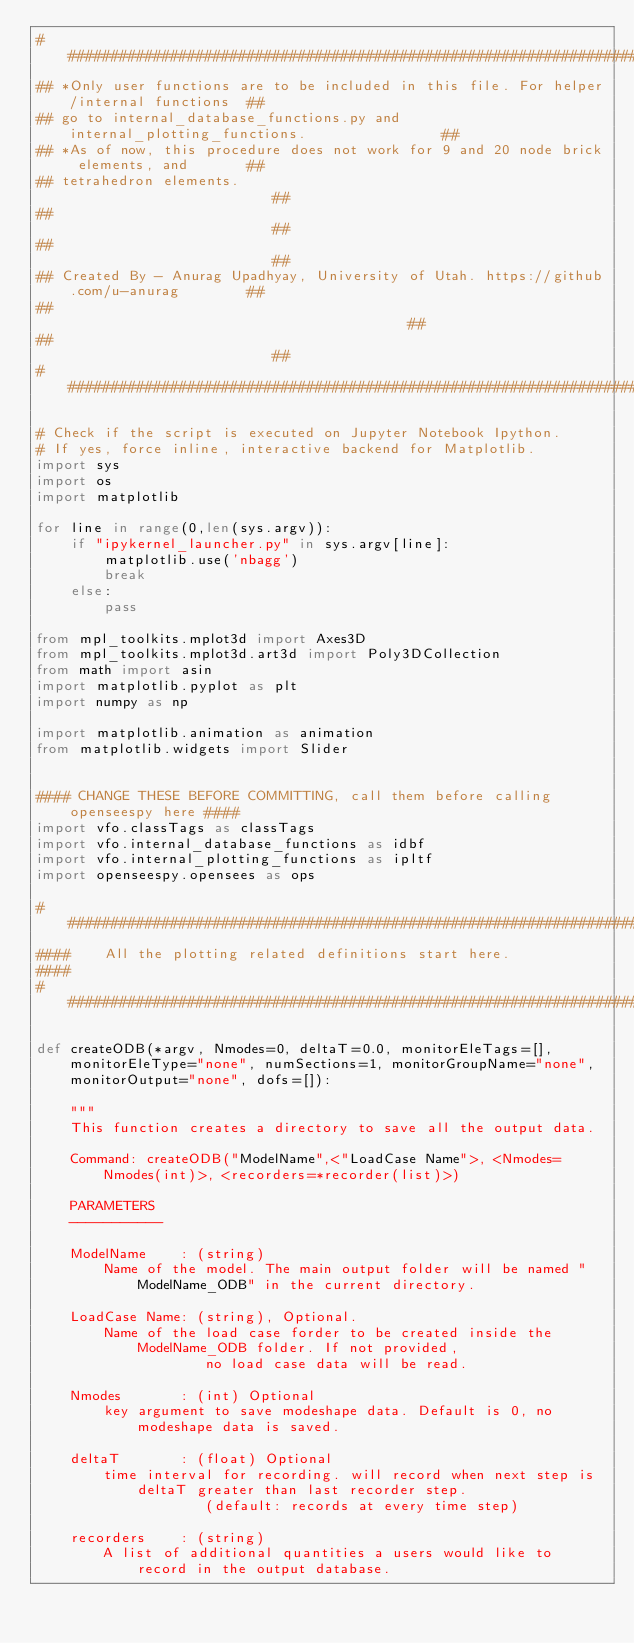<code> <loc_0><loc_0><loc_500><loc_500><_Python_>##########################################################################################
## *Only user functions are to be included in this file. For helper/internal functions	##
## go to internal_database_functions.py and internal_plotting_functions.                ##
## *As of now, this procedure does not work for 9 and 20 node brick elements, and       ##
## tetrahedron elements.																##
##																						##
##																						##
## Created By - Anurag Upadhyay, University of Utah. https://github.com/u-anurag		##
##            									                                        ##
## 																						##
##########################################################################################

# Check if the script is executed on Jupyter Notebook Ipython. 
# If yes, force inline, interactive backend for Matplotlib.
import sys
import os
import matplotlib

for line in range(0,len(sys.argv)):
    if "ipykernel_launcher.py" in sys.argv[line]:
        matplotlib.use('nbagg')
        break
    else:
        pass

from mpl_toolkits.mplot3d import Axes3D
from mpl_toolkits.mplot3d.art3d import Poly3DCollection
from math import asin
import matplotlib.pyplot as plt
import numpy as np

import matplotlib.animation as animation
from matplotlib.widgets import Slider


#### CHANGE THESE BEFORE COMMITTING, call them before calling openseespy here ####
import vfo.classTags as classTags
import vfo.internal_database_functions as idbf
import vfo.internal_plotting_functions as ipltf
import openseespy.opensees as ops

#####################################################################
####    All the plotting related definitions start here.
####
#####################################################################

def createODB(*argv, Nmodes=0, deltaT=0.0, monitorEleTags=[], monitorEleType="none", numSections=1, monitorGroupName="none", monitorOutput="none", dofs=[]):
	
	"""
	This function creates a directory to save all the output data.

	Command: createODB("ModelName",<"LoadCase Name">, <Nmodes=Nmodes(int)>, <recorders=*recorder(list)>)
	
	PARAMETERS
	-----------
	
	ModelName    : (string) 
		Name of the model. The main output folder will be named "ModelName_ODB" in the current directory.
		
	LoadCase Name: (string), Optional. 
		Name of the load case forder to be created inside the ModelName_ODB folder. If not provided,
					no load case data will be read.
					
	Nmodes		 : (int) Optional 
		key argument to save modeshape data. Default is 0, no modeshape data is saved.
	
	deltaT		 : (float) Optional 
		time interval for recording. will record when next step is deltaT greater than last recorder step. 
					(default: records at every time step)
	
	recorders	 : (string) 
		A list of additional quantities a users would like to record in the output database.</code> 